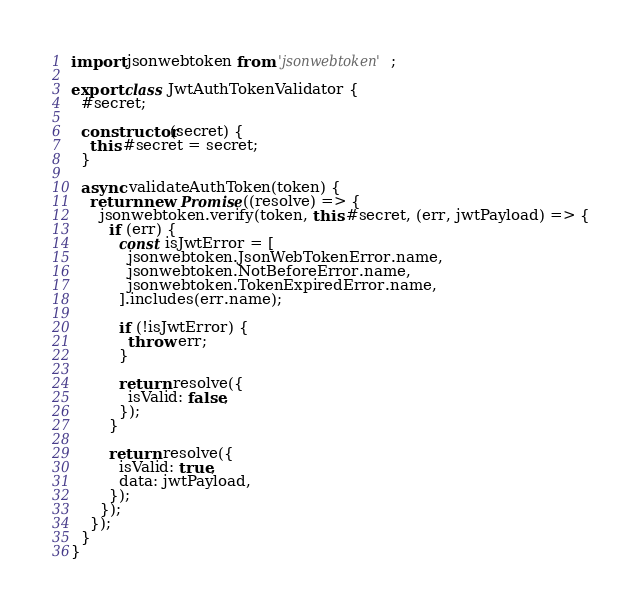Convert code to text. <code><loc_0><loc_0><loc_500><loc_500><_JavaScript_>import jsonwebtoken from 'jsonwebtoken';

export class JwtAuthTokenValidator {
  #secret;

  constructor(secret) {
    this.#secret = secret;
  }

  async validateAuthToken(token) {
    return new Promise((resolve) => {
      jsonwebtoken.verify(token, this.#secret, (err, jwtPayload) => {
        if (err) {
          const isJwtError = [
            jsonwebtoken.JsonWebTokenError.name,
            jsonwebtoken.NotBeforeError.name,
            jsonwebtoken.TokenExpiredError.name,
          ].includes(err.name);

          if (!isJwtError) {
            throw err;
          }

          return resolve({
            isValid: false,
          });
        }

        return resolve({
          isValid: true,
          data: jwtPayload,
        });
      });
    });
  }
}
</code> 